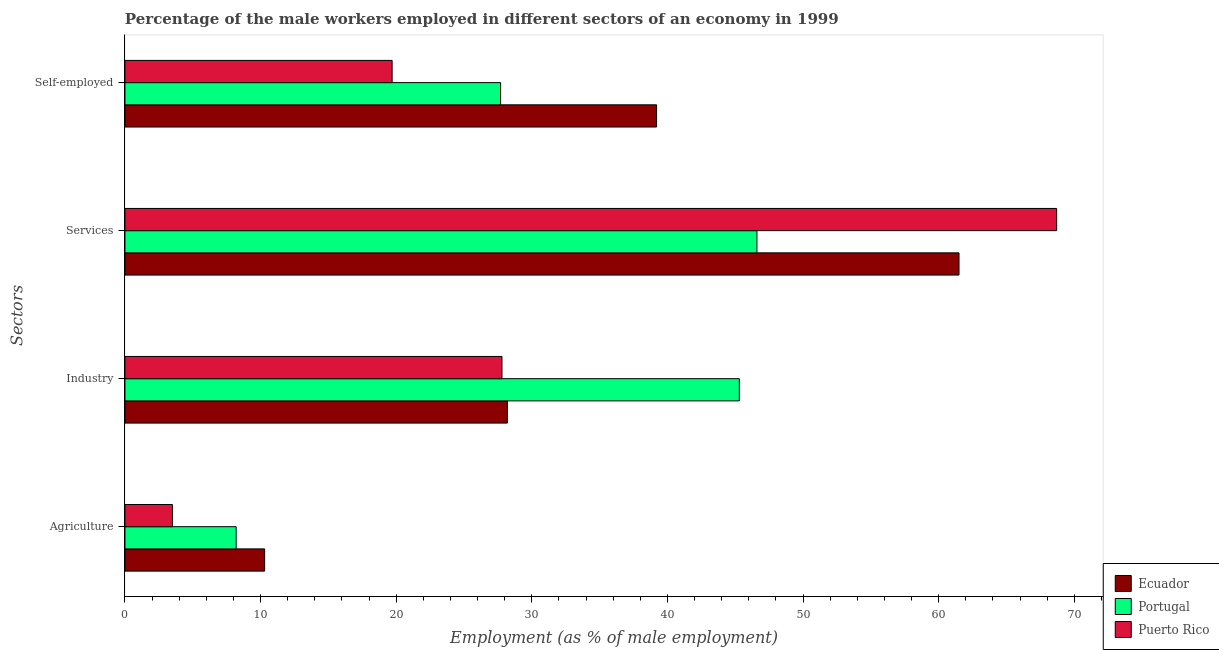Are the number of bars per tick equal to the number of legend labels?
Keep it short and to the point. Yes. Are the number of bars on each tick of the Y-axis equal?
Provide a succinct answer. Yes. What is the label of the 1st group of bars from the top?
Offer a very short reply. Self-employed. What is the percentage of male workers in services in Ecuador?
Give a very brief answer. 61.5. Across all countries, what is the maximum percentage of self employed male workers?
Offer a terse response. 39.2. Across all countries, what is the minimum percentage of self employed male workers?
Provide a short and direct response. 19.7. In which country was the percentage of self employed male workers maximum?
Make the answer very short. Ecuador. In which country was the percentage of male workers in services minimum?
Your answer should be very brief. Portugal. What is the total percentage of male workers in industry in the graph?
Provide a short and direct response. 101.3. What is the difference between the percentage of male workers in services in Ecuador and that in Portugal?
Provide a succinct answer. 14.9. What is the difference between the percentage of self employed male workers in Puerto Rico and the percentage of male workers in services in Portugal?
Ensure brevity in your answer.  -26.9. What is the average percentage of male workers in industry per country?
Your answer should be compact. 33.77. What is the difference between the percentage of male workers in industry and percentage of male workers in services in Portugal?
Your answer should be compact. -1.3. In how many countries, is the percentage of male workers in agriculture greater than 44 %?
Offer a very short reply. 0. What is the ratio of the percentage of self employed male workers in Ecuador to that in Portugal?
Offer a terse response. 1.42. Is the percentage of male workers in industry in Ecuador less than that in Puerto Rico?
Your answer should be compact. No. What is the difference between the highest and the second highest percentage of self employed male workers?
Offer a very short reply. 11.5. What is the difference between the highest and the lowest percentage of male workers in industry?
Make the answer very short. 17.5. In how many countries, is the percentage of male workers in agriculture greater than the average percentage of male workers in agriculture taken over all countries?
Make the answer very short. 2. Is it the case that in every country, the sum of the percentage of male workers in industry and percentage of male workers in services is greater than the sum of percentage of self employed male workers and percentage of male workers in agriculture?
Offer a very short reply. No. What does the 3rd bar from the top in Industry represents?
Your response must be concise. Ecuador. What does the 1st bar from the bottom in Self-employed represents?
Ensure brevity in your answer.  Ecuador. How many bars are there?
Provide a succinct answer. 12. Are all the bars in the graph horizontal?
Your response must be concise. Yes. How many countries are there in the graph?
Your answer should be compact. 3. What is the difference between two consecutive major ticks on the X-axis?
Your response must be concise. 10. Are the values on the major ticks of X-axis written in scientific E-notation?
Provide a short and direct response. No. Does the graph contain grids?
Ensure brevity in your answer.  No. Where does the legend appear in the graph?
Your response must be concise. Bottom right. How many legend labels are there?
Make the answer very short. 3. What is the title of the graph?
Keep it short and to the point. Percentage of the male workers employed in different sectors of an economy in 1999. Does "Qatar" appear as one of the legend labels in the graph?
Your answer should be compact. No. What is the label or title of the X-axis?
Make the answer very short. Employment (as % of male employment). What is the label or title of the Y-axis?
Provide a short and direct response. Sectors. What is the Employment (as % of male employment) in Ecuador in Agriculture?
Your answer should be very brief. 10.3. What is the Employment (as % of male employment) of Portugal in Agriculture?
Your response must be concise. 8.2. What is the Employment (as % of male employment) of Ecuador in Industry?
Give a very brief answer. 28.2. What is the Employment (as % of male employment) of Portugal in Industry?
Provide a succinct answer. 45.3. What is the Employment (as % of male employment) in Puerto Rico in Industry?
Your answer should be compact. 27.8. What is the Employment (as % of male employment) in Ecuador in Services?
Make the answer very short. 61.5. What is the Employment (as % of male employment) of Portugal in Services?
Your answer should be very brief. 46.6. What is the Employment (as % of male employment) of Puerto Rico in Services?
Provide a succinct answer. 68.7. What is the Employment (as % of male employment) in Ecuador in Self-employed?
Provide a short and direct response. 39.2. What is the Employment (as % of male employment) in Portugal in Self-employed?
Your answer should be very brief. 27.7. What is the Employment (as % of male employment) in Puerto Rico in Self-employed?
Make the answer very short. 19.7. Across all Sectors, what is the maximum Employment (as % of male employment) of Ecuador?
Provide a succinct answer. 61.5. Across all Sectors, what is the maximum Employment (as % of male employment) of Portugal?
Ensure brevity in your answer.  46.6. Across all Sectors, what is the maximum Employment (as % of male employment) of Puerto Rico?
Offer a terse response. 68.7. Across all Sectors, what is the minimum Employment (as % of male employment) in Ecuador?
Your answer should be compact. 10.3. Across all Sectors, what is the minimum Employment (as % of male employment) of Portugal?
Offer a terse response. 8.2. What is the total Employment (as % of male employment) of Ecuador in the graph?
Your answer should be compact. 139.2. What is the total Employment (as % of male employment) in Portugal in the graph?
Provide a succinct answer. 127.8. What is the total Employment (as % of male employment) of Puerto Rico in the graph?
Keep it short and to the point. 119.7. What is the difference between the Employment (as % of male employment) of Ecuador in Agriculture and that in Industry?
Offer a terse response. -17.9. What is the difference between the Employment (as % of male employment) of Portugal in Agriculture and that in Industry?
Offer a terse response. -37.1. What is the difference between the Employment (as % of male employment) in Puerto Rico in Agriculture and that in Industry?
Provide a short and direct response. -24.3. What is the difference between the Employment (as % of male employment) in Ecuador in Agriculture and that in Services?
Make the answer very short. -51.2. What is the difference between the Employment (as % of male employment) of Portugal in Agriculture and that in Services?
Offer a very short reply. -38.4. What is the difference between the Employment (as % of male employment) of Puerto Rico in Agriculture and that in Services?
Provide a short and direct response. -65.2. What is the difference between the Employment (as % of male employment) in Ecuador in Agriculture and that in Self-employed?
Offer a very short reply. -28.9. What is the difference between the Employment (as % of male employment) in Portugal in Agriculture and that in Self-employed?
Provide a succinct answer. -19.5. What is the difference between the Employment (as % of male employment) in Puerto Rico in Agriculture and that in Self-employed?
Keep it short and to the point. -16.2. What is the difference between the Employment (as % of male employment) in Ecuador in Industry and that in Services?
Keep it short and to the point. -33.3. What is the difference between the Employment (as % of male employment) in Portugal in Industry and that in Services?
Your answer should be compact. -1.3. What is the difference between the Employment (as % of male employment) in Puerto Rico in Industry and that in Services?
Keep it short and to the point. -40.9. What is the difference between the Employment (as % of male employment) in Ecuador in Industry and that in Self-employed?
Make the answer very short. -11. What is the difference between the Employment (as % of male employment) of Ecuador in Services and that in Self-employed?
Your answer should be compact. 22.3. What is the difference between the Employment (as % of male employment) in Portugal in Services and that in Self-employed?
Provide a short and direct response. 18.9. What is the difference between the Employment (as % of male employment) in Puerto Rico in Services and that in Self-employed?
Ensure brevity in your answer.  49. What is the difference between the Employment (as % of male employment) of Ecuador in Agriculture and the Employment (as % of male employment) of Portugal in Industry?
Ensure brevity in your answer.  -35. What is the difference between the Employment (as % of male employment) in Ecuador in Agriculture and the Employment (as % of male employment) in Puerto Rico in Industry?
Give a very brief answer. -17.5. What is the difference between the Employment (as % of male employment) of Portugal in Agriculture and the Employment (as % of male employment) of Puerto Rico in Industry?
Your answer should be very brief. -19.6. What is the difference between the Employment (as % of male employment) of Ecuador in Agriculture and the Employment (as % of male employment) of Portugal in Services?
Give a very brief answer. -36.3. What is the difference between the Employment (as % of male employment) in Ecuador in Agriculture and the Employment (as % of male employment) in Puerto Rico in Services?
Make the answer very short. -58.4. What is the difference between the Employment (as % of male employment) of Portugal in Agriculture and the Employment (as % of male employment) of Puerto Rico in Services?
Provide a succinct answer. -60.5. What is the difference between the Employment (as % of male employment) of Ecuador in Agriculture and the Employment (as % of male employment) of Portugal in Self-employed?
Provide a short and direct response. -17.4. What is the difference between the Employment (as % of male employment) of Ecuador in Industry and the Employment (as % of male employment) of Portugal in Services?
Make the answer very short. -18.4. What is the difference between the Employment (as % of male employment) in Ecuador in Industry and the Employment (as % of male employment) in Puerto Rico in Services?
Your answer should be very brief. -40.5. What is the difference between the Employment (as % of male employment) in Portugal in Industry and the Employment (as % of male employment) in Puerto Rico in Services?
Provide a short and direct response. -23.4. What is the difference between the Employment (as % of male employment) of Ecuador in Industry and the Employment (as % of male employment) of Portugal in Self-employed?
Your answer should be compact. 0.5. What is the difference between the Employment (as % of male employment) of Portugal in Industry and the Employment (as % of male employment) of Puerto Rico in Self-employed?
Provide a succinct answer. 25.6. What is the difference between the Employment (as % of male employment) of Ecuador in Services and the Employment (as % of male employment) of Portugal in Self-employed?
Keep it short and to the point. 33.8. What is the difference between the Employment (as % of male employment) of Ecuador in Services and the Employment (as % of male employment) of Puerto Rico in Self-employed?
Your response must be concise. 41.8. What is the difference between the Employment (as % of male employment) of Portugal in Services and the Employment (as % of male employment) of Puerto Rico in Self-employed?
Your response must be concise. 26.9. What is the average Employment (as % of male employment) in Ecuador per Sectors?
Offer a very short reply. 34.8. What is the average Employment (as % of male employment) of Portugal per Sectors?
Your answer should be compact. 31.95. What is the average Employment (as % of male employment) in Puerto Rico per Sectors?
Your answer should be compact. 29.93. What is the difference between the Employment (as % of male employment) of Ecuador and Employment (as % of male employment) of Puerto Rico in Agriculture?
Your answer should be compact. 6.8. What is the difference between the Employment (as % of male employment) of Portugal and Employment (as % of male employment) of Puerto Rico in Agriculture?
Offer a very short reply. 4.7. What is the difference between the Employment (as % of male employment) of Ecuador and Employment (as % of male employment) of Portugal in Industry?
Your response must be concise. -17.1. What is the difference between the Employment (as % of male employment) in Ecuador and Employment (as % of male employment) in Puerto Rico in Industry?
Your answer should be very brief. 0.4. What is the difference between the Employment (as % of male employment) in Portugal and Employment (as % of male employment) in Puerto Rico in Industry?
Offer a terse response. 17.5. What is the difference between the Employment (as % of male employment) of Ecuador and Employment (as % of male employment) of Puerto Rico in Services?
Your response must be concise. -7.2. What is the difference between the Employment (as % of male employment) in Portugal and Employment (as % of male employment) in Puerto Rico in Services?
Keep it short and to the point. -22.1. What is the difference between the Employment (as % of male employment) of Ecuador and Employment (as % of male employment) of Portugal in Self-employed?
Offer a terse response. 11.5. What is the ratio of the Employment (as % of male employment) in Ecuador in Agriculture to that in Industry?
Your answer should be very brief. 0.37. What is the ratio of the Employment (as % of male employment) in Portugal in Agriculture to that in Industry?
Make the answer very short. 0.18. What is the ratio of the Employment (as % of male employment) of Puerto Rico in Agriculture to that in Industry?
Ensure brevity in your answer.  0.13. What is the ratio of the Employment (as % of male employment) in Ecuador in Agriculture to that in Services?
Make the answer very short. 0.17. What is the ratio of the Employment (as % of male employment) in Portugal in Agriculture to that in Services?
Keep it short and to the point. 0.18. What is the ratio of the Employment (as % of male employment) in Puerto Rico in Agriculture to that in Services?
Provide a succinct answer. 0.05. What is the ratio of the Employment (as % of male employment) in Ecuador in Agriculture to that in Self-employed?
Give a very brief answer. 0.26. What is the ratio of the Employment (as % of male employment) of Portugal in Agriculture to that in Self-employed?
Your answer should be compact. 0.3. What is the ratio of the Employment (as % of male employment) in Puerto Rico in Agriculture to that in Self-employed?
Your response must be concise. 0.18. What is the ratio of the Employment (as % of male employment) of Ecuador in Industry to that in Services?
Give a very brief answer. 0.46. What is the ratio of the Employment (as % of male employment) in Portugal in Industry to that in Services?
Provide a succinct answer. 0.97. What is the ratio of the Employment (as % of male employment) in Puerto Rico in Industry to that in Services?
Your answer should be very brief. 0.4. What is the ratio of the Employment (as % of male employment) of Ecuador in Industry to that in Self-employed?
Ensure brevity in your answer.  0.72. What is the ratio of the Employment (as % of male employment) of Portugal in Industry to that in Self-employed?
Ensure brevity in your answer.  1.64. What is the ratio of the Employment (as % of male employment) in Puerto Rico in Industry to that in Self-employed?
Make the answer very short. 1.41. What is the ratio of the Employment (as % of male employment) of Ecuador in Services to that in Self-employed?
Offer a very short reply. 1.57. What is the ratio of the Employment (as % of male employment) in Portugal in Services to that in Self-employed?
Your answer should be very brief. 1.68. What is the ratio of the Employment (as % of male employment) in Puerto Rico in Services to that in Self-employed?
Your answer should be very brief. 3.49. What is the difference between the highest and the second highest Employment (as % of male employment) in Ecuador?
Offer a very short reply. 22.3. What is the difference between the highest and the second highest Employment (as % of male employment) in Portugal?
Offer a very short reply. 1.3. What is the difference between the highest and the second highest Employment (as % of male employment) in Puerto Rico?
Offer a terse response. 40.9. What is the difference between the highest and the lowest Employment (as % of male employment) of Ecuador?
Keep it short and to the point. 51.2. What is the difference between the highest and the lowest Employment (as % of male employment) of Portugal?
Offer a terse response. 38.4. What is the difference between the highest and the lowest Employment (as % of male employment) of Puerto Rico?
Your answer should be compact. 65.2. 